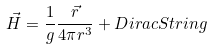Convert formula to latex. <formula><loc_0><loc_0><loc_500><loc_500>\vec { H } = \frac { 1 } { g } \frac { \vec { r } } { 4 \pi r ^ { 3 } } + D i r a c S t r i n g</formula> 